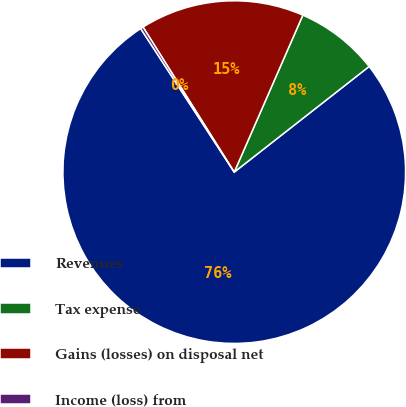<chart> <loc_0><loc_0><loc_500><loc_500><pie_chart><fcel>Revenues<fcel>Tax expense<fcel>Gains (losses) on disposal net<fcel>Income (loss) from<nl><fcel>76.38%<fcel>7.87%<fcel>15.49%<fcel>0.26%<nl></chart> 